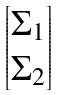Convert formula to latex. <formula><loc_0><loc_0><loc_500><loc_500>\begin{bmatrix} \Sigma _ { 1 } \\ \Sigma _ { 2 } \end{bmatrix}</formula> 